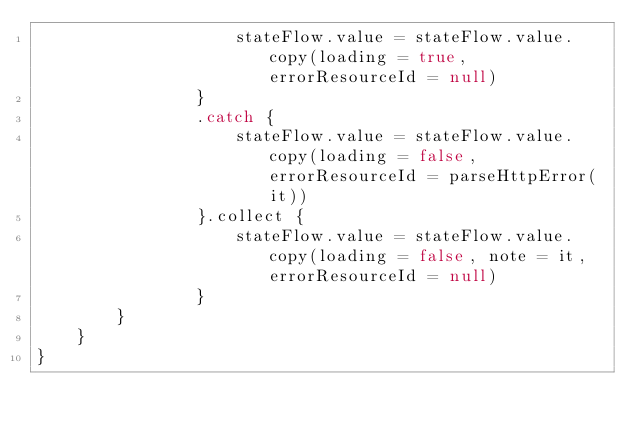Convert code to text. <code><loc_0><loc_0><loc_500><loc_500><_Kotlin_>                    stateFlow.value = stateFlow.value.copy(loading = true, errorResourceId = null)
                }
                .catch {
                    stateFlow.value = stateFlow.value.copy(loading = false, errorResourceId = parseHttpError(it))
                }.collect {
                    stateFlow.value = stateFlow.value.copy(loading = false, note = it, errorResourceId = null)
                }
        }
    }
}</code> 